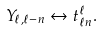<formula> <loc_0><loc_0><loc_500><loc_500>Y _ { \ell , \ell - n } \leftrightarrow t _ { \ell n } ^ { \ell } .</formula> 